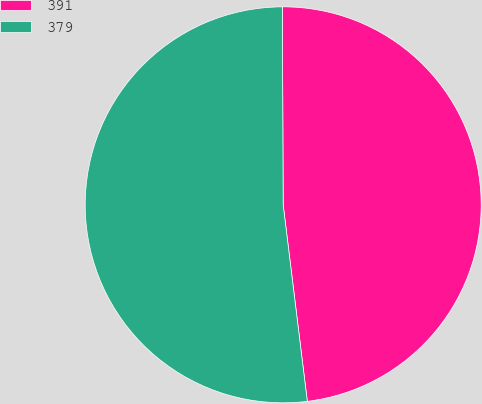<chart> <loc_0><loc_0><loc_500><loc_500><pie_chart><fcel>391<fcel>379<nl><fcel>48.12%<fcel>51.88%<nl></chart> 